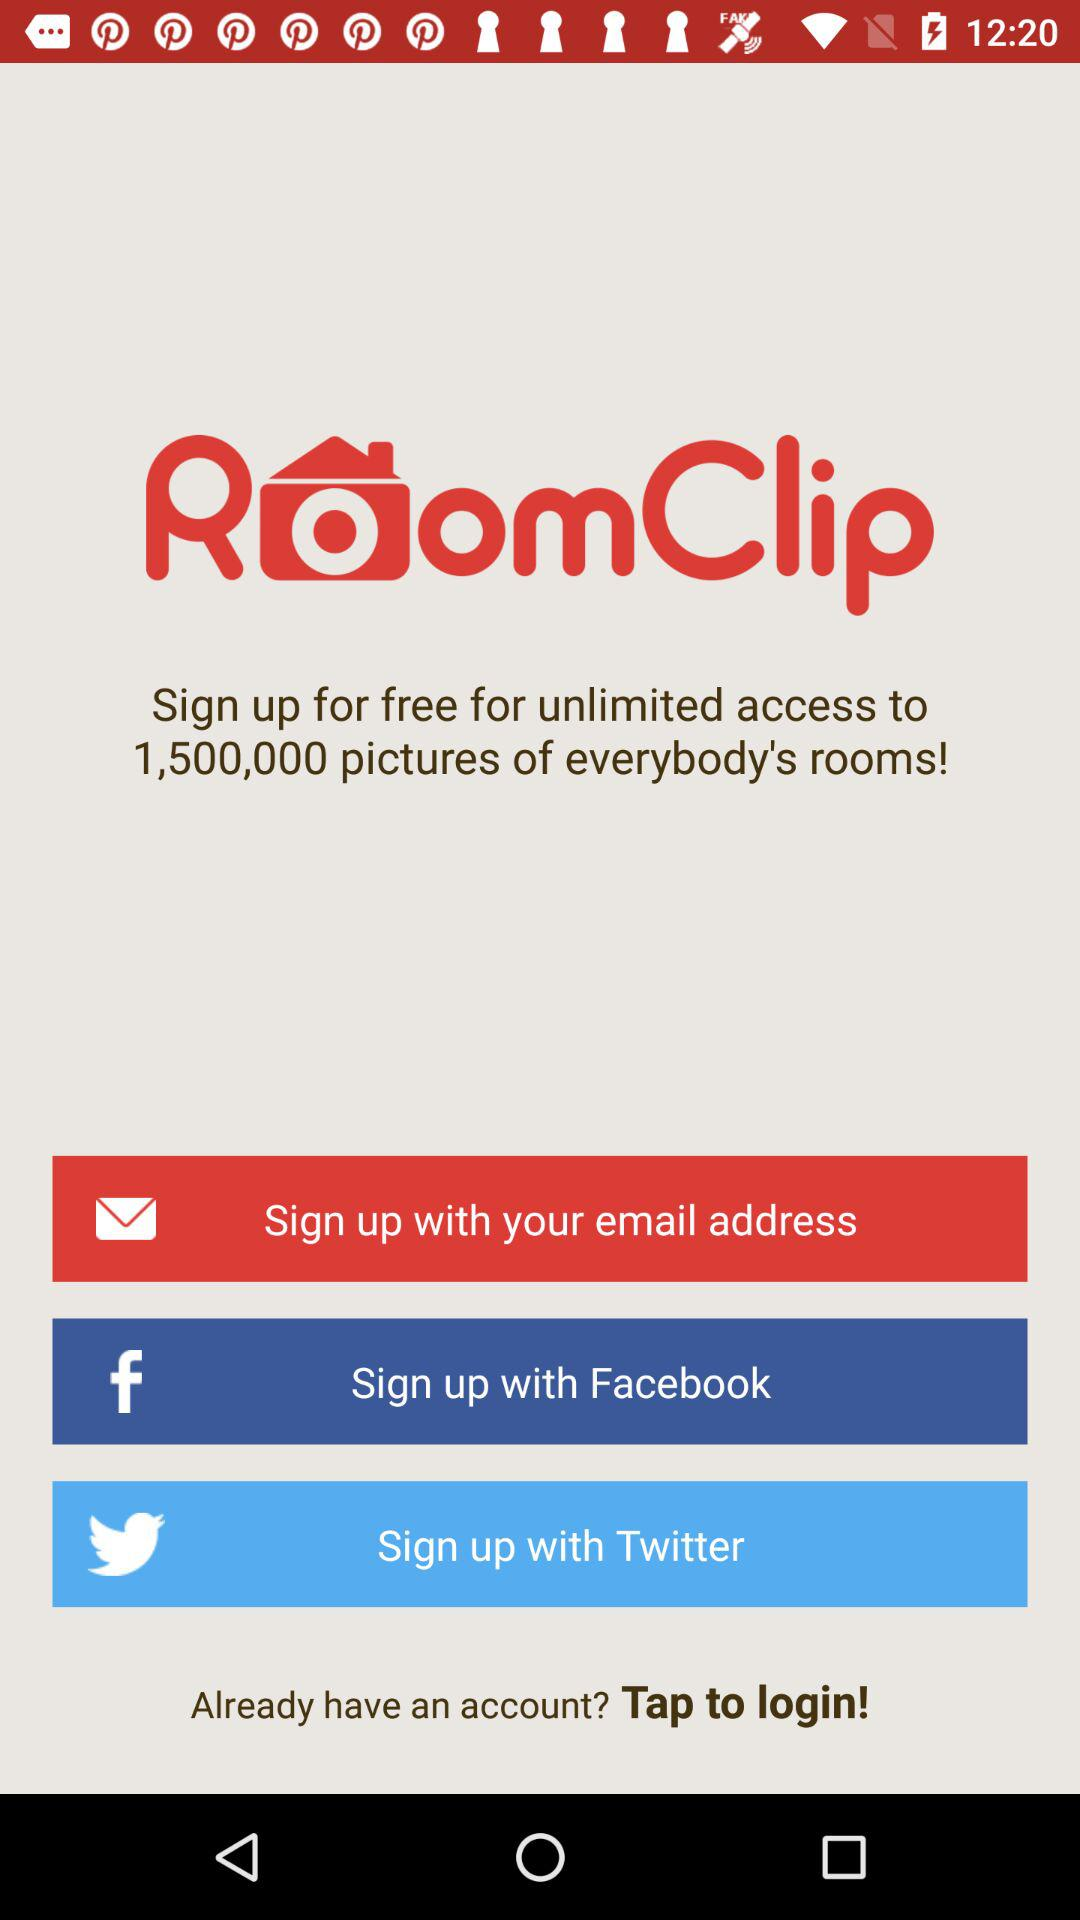What is the name of the application? The name of the application is "RoomClip". 